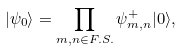Convert formula to latex. <formula><loc_0><loc_0><loc_500><loc_500>| \psi _ { 0 } \rangle = \prod _ { m , n \in F . S . } \psi _ { m , n } ^ { + } | 0 \rangle ,</formula> 